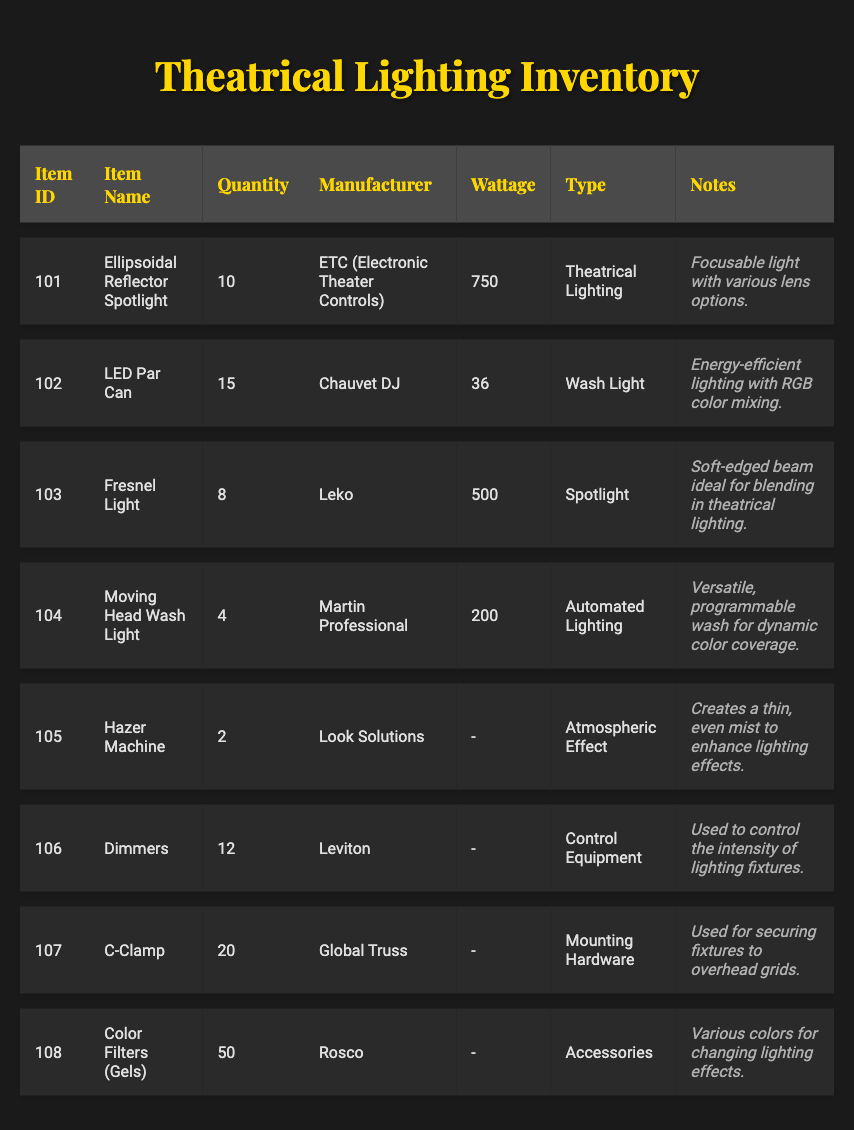What is the quantity of the Hazer Machine? The quantity column lists the items and their quantities. For the Hazer Machine, the quantity is directly stated as 2.
Answer: 2 Which manufacturer produces the Moving Head Wash Light? The table shows the Moving Head Wash Light in one of the rows, and its manufacturer is indicated as Martin Professional.
Answer: Martin Professional How many LED Par Can units are available compared to Fresnel Lights? The LED Par Can quantity is 15 and the Fresnel Light quantity is 8. To find out how many more LED Par Can units there are than Fresnel Lights, subtract: 15 - 8 = 7.
Answer: 7 Is the Ellipsoidal Reflector Spotlight a type of spotlight? The type for the Ellipsoidal Reflector Spotlight in the table is marked as Theatrical Lighting, which indicates it is used for spotlighting. Hence, it can be considered a type of spotlight.
Answer: Yes What is the total wattage of all units of Dimmers? The Dimmers are listed as having no wattage in the table, indicating they do not consume power in the same way as other lighting fixtures. Therefore, the total wattage summed from the available data is 0.
Answer: 0 How many different types of lighting equipment are categorized as Accessories? In the table, only the Color Filters (Gels) item is under the Accessories type, so there is one item in that category.
Answer: 1 Which lighting equipment has the lowest wattage in this inventory? A quick glance through the wattage column shows that the LED Par Can has the lowest wattage at 36 watts. Comparatively, all other items have higher wattage.
Answer: LED Par Can What is the average quantity of all lighting equipment types listed? To calculate the average, sum the quantities: 10 + 15 + 8 + 4 + 2 + 12 + 20 + 50 = 121. Then divide by the number of items, which is 8: 121 / 8 = 15.125. Rounding to the nearest whole number gives an average of 15.
Answer: 15 How many more C-Clamps are there than Hazer Machines? The quantity of C-Clamps is 20, while the quantity of Hazer Machines is 2. To find the difference: 20 - 2 = 18.
Answer: 18 